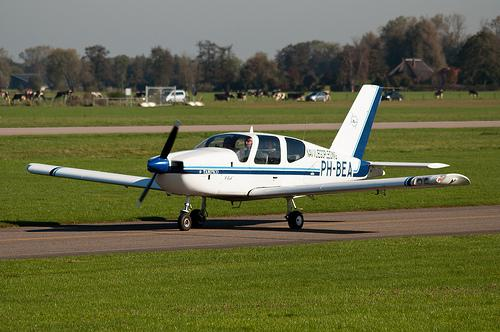Question: what color is the plane?
Choices:
A. The plane is blue and white.
B. Red.
C. Tan.
D. Orange.
Answer with the letter. Answer: A Question: how many people are on the plane?
Choices:
A. Three.
B. Four.
C. 1 person on the plane.
D. Two.
Answer with the letter. Answer: C Question: where was the picture taken?
Choices:
A. At the airport.
B. On a plane.
C. On the runway.
D. In the lobby.
Answer with the letter. Answer: C 